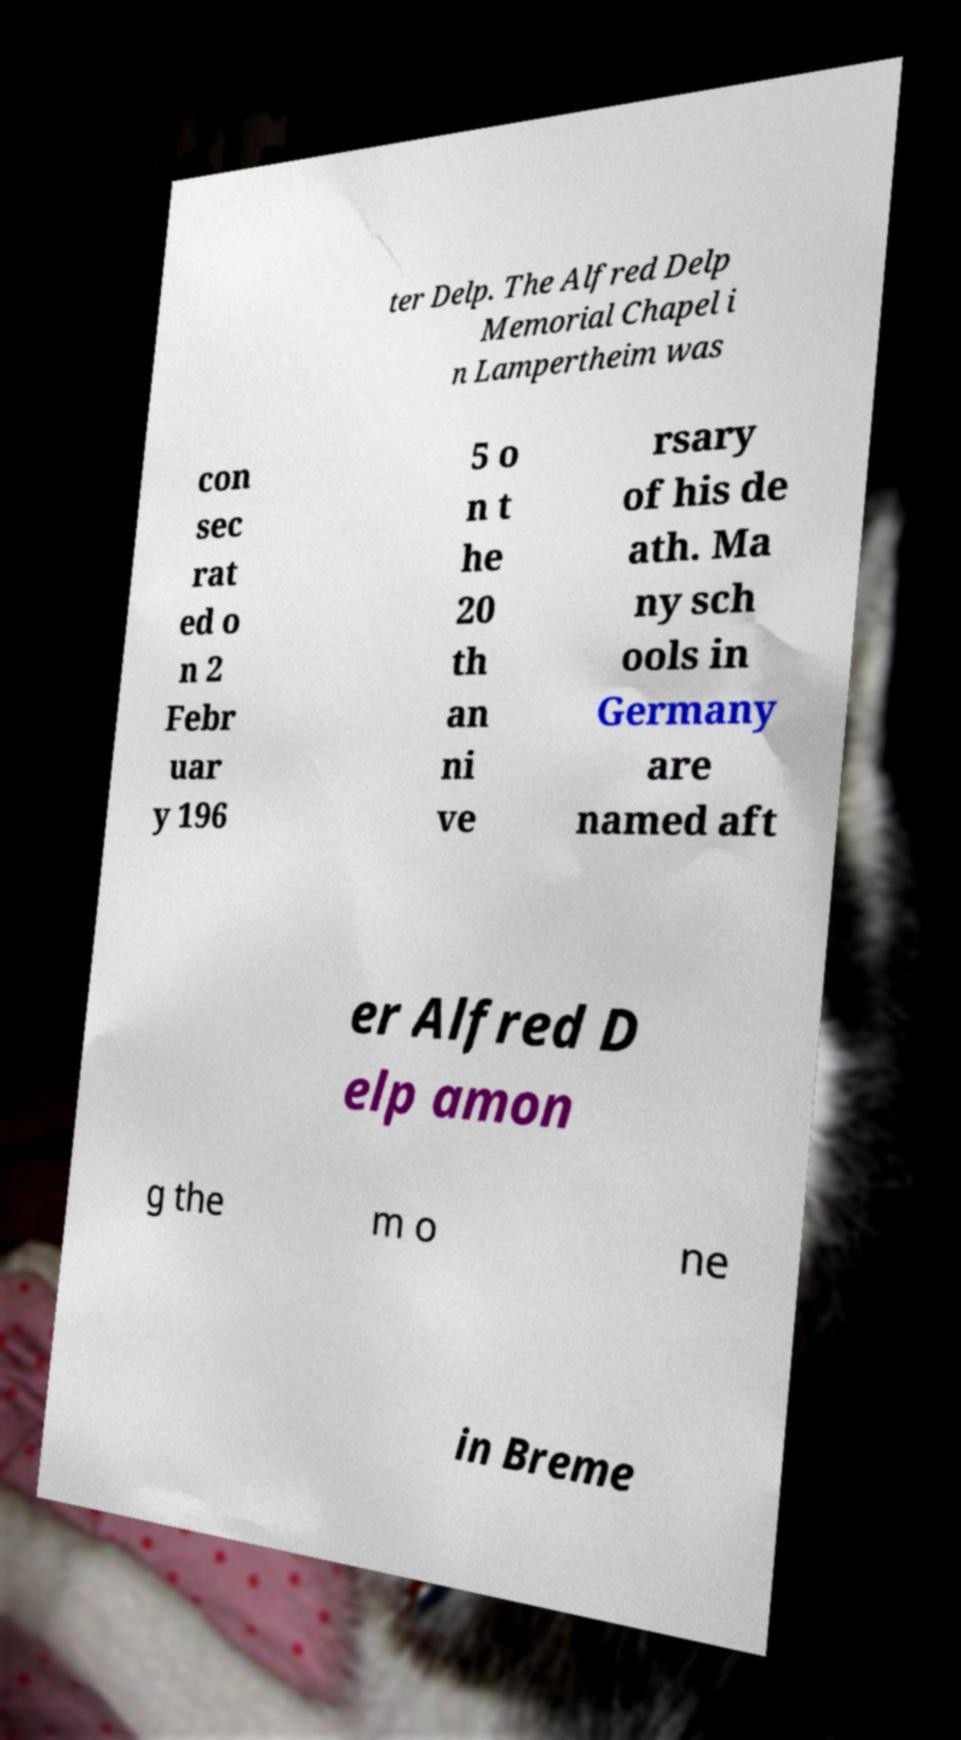Please read and relay the text visible in this image. What does it say? ter Delp. The Alfred Delp Memorial Chapel i n Lampertheim was con sec rat ed o n 2 Febr uar y 196 5 o n t he 20 th an ni ve rsary of his de ath. Ma ny sch ools in Germany are named aft er Alfred D elp amon g the m o ne in Breme 